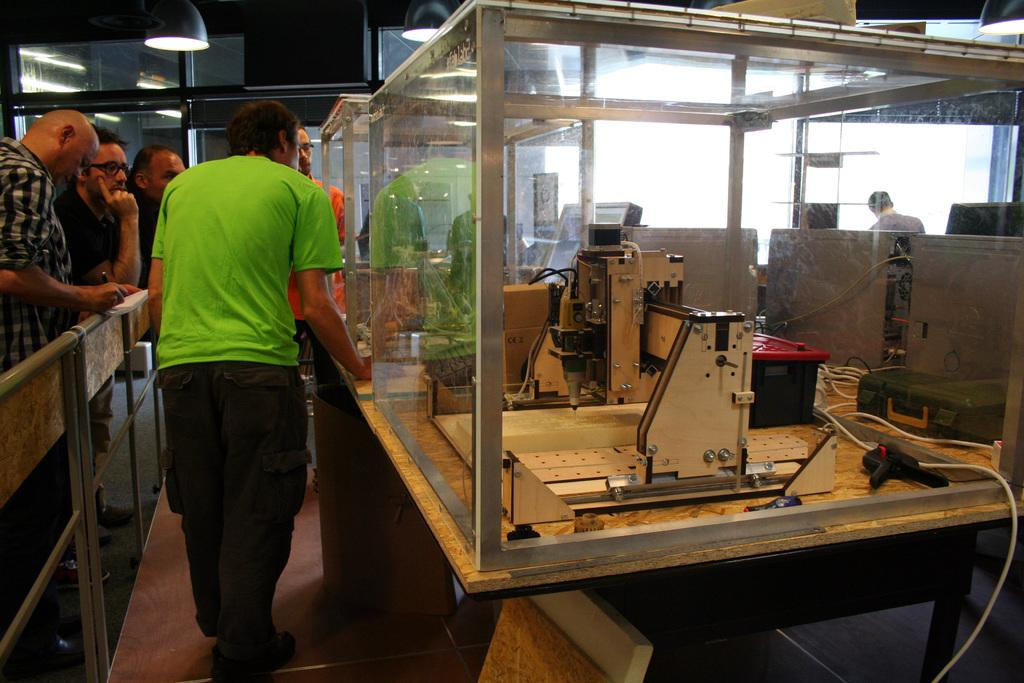Who or what can be seen in the image? There are people in the image. What else is present in the image besides the people? There are many objects and lights in the image. Can you describe the reflection in the image? There is a reflection of a person on the glass in the image. What type of cake is being served in the morning by the guide in the image? There is no cake, morning, or guide present in the image. 